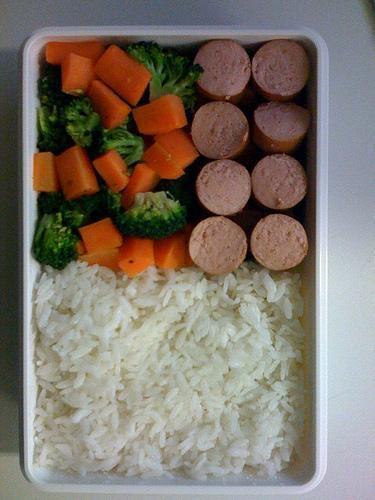How many sausages are on the tray?
Give a very brief answer. 8. How many eggs are in the box?
Give a very brief answer. 0. How many compartments are there?
Give a very brief answer. 3. How many broccolis are there?
Give a very brief answer. 5. How many hot dogs are in the picture?
Give a very brief answer. 7. How many birds are going to fly there in the image?
Give a very brief answer. 0. 